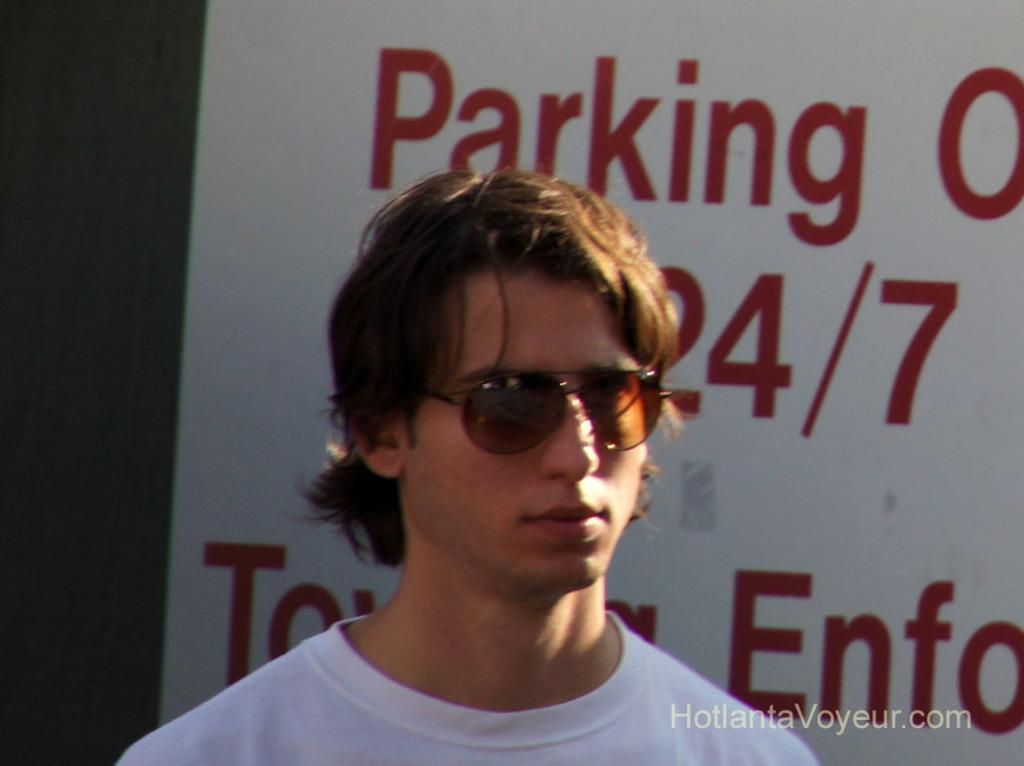Can you describe this image briefly? In this image we can see a person. There is a white board behind a person on which there is some text. 